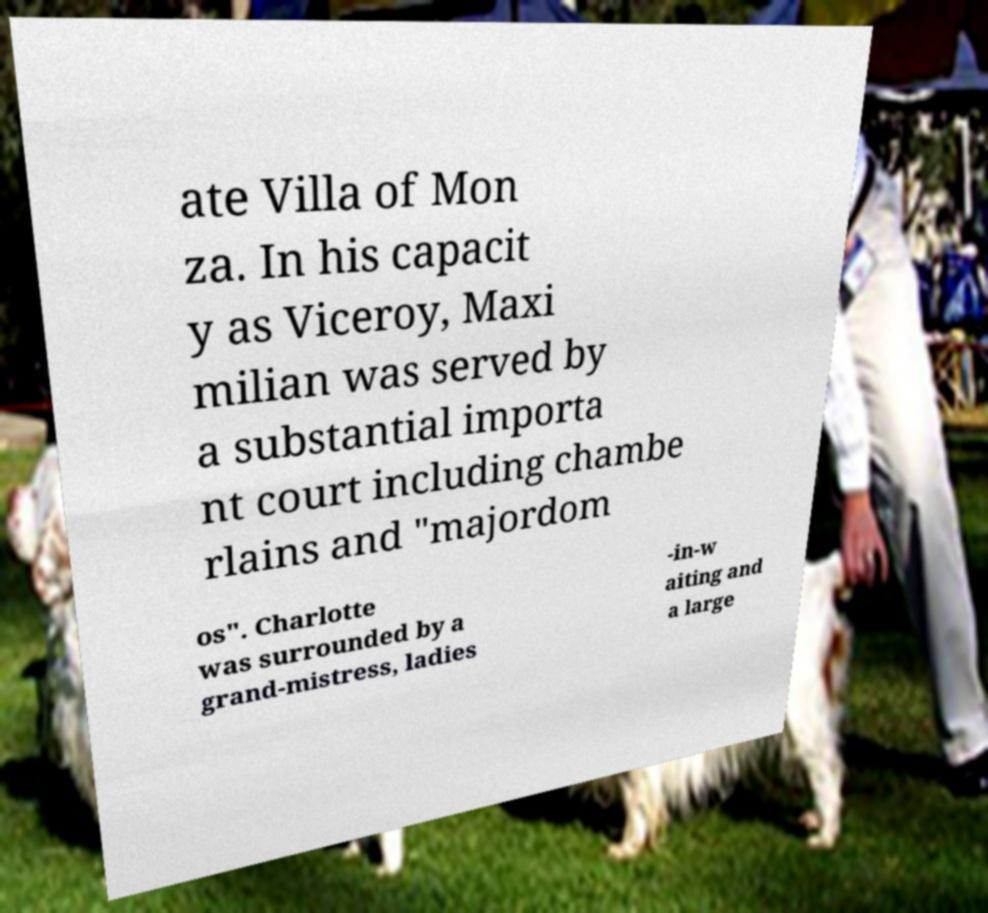Could you extract and type out the text from this image? ate Villa of Mon za. In his capacit y as Viceroy, Maxi milian was served by a substantial importa nt court including chambe rlains and "majordom os". Charlotte was surrounded by a grand-mistress, ladies -in-w aiting and a large 